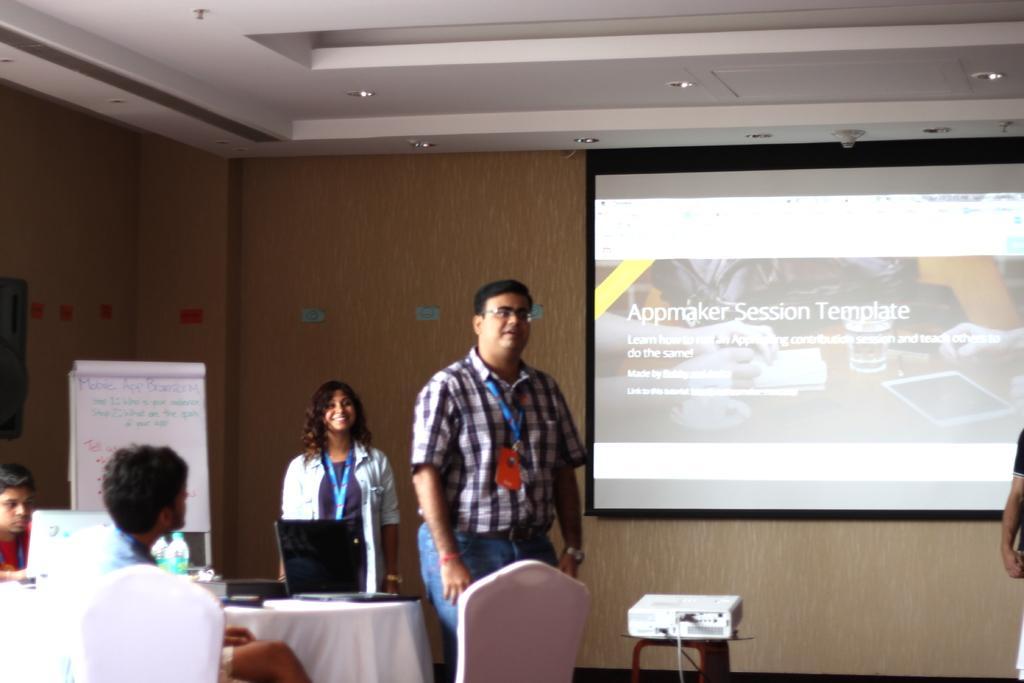Please provide a concise description of this image. As we can see in the image there is a wall, screen and few people standing and sitting, a projector and a white color board. 